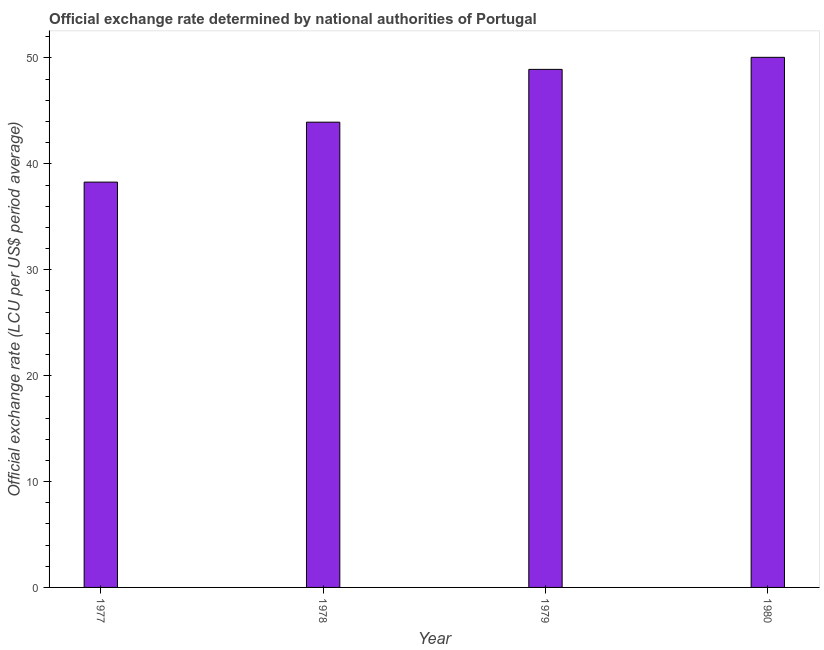Does the graph contain grids?
Provide a succinct answer. No. What is the title of the graph?
Keep it short and to the point. Official exchange rate determined by national authorities of Portugal. What is the label or title of the X-axis?
Offer a very short reply. Year. What is the label or title of the Y-axis?
Offer a terse response. Official exchange rate (LCU per US$ period average). What is the official exchange rate in 1978?
Your answer should be very brief. 43.94. Across all years, what is the maximum official exchange rate?
Make the answer very short. 50.06. Across all years, what is the minimum official exchange rate?
Your answer should be compact. 38.28. In which year was the official exchange rate maximum?
Your answer should be compact. 1980. What is the sum of the official exchange rate?
Provide a short and direct response. 181.2. What is the difference between the official exchange rate in 1978 and 1979?
Offer a very short reply. -4.99. What is the average official exchange rate per year?
Provide a short and direct response. 45.3. What is the median official exchange rate?
Offer a terse response. 46.43. In how many years, is the official exchange rate greater than 36 ?
Ensure brevity in your answer.  4. What is the ratio of the official exchange rate in 1977 to that in 1978?
Make the answer very short. 0.87. Is the official exchange rate in 1977 less than that in 1980?
Give a very brief answer. Yes. What is the difference between the highest and the second highest official exchange rate?
Keep it short and to the point. 1.14. What is the difference between the highest and the lowest official exchange rate?
Offer a very short reply. 11.79. In how many years, is the official exchange rate greater than the average official exchange rate taken over all years?
Provide a succinct answer. 2. How many years are there in the graph?
Give a very brief answer. 4. What is the Official exchange rate (LCU per US$ period average) in 1977?
Offer a very short reply. 38.28. What is the Official exchange rate (LCU per US$ period average) of 1978?
Your answer should be very brief. 43.94. What is the Official exchange rate (LCU per US$ period average) in 1979?
Ensure brevity in your answer.  48.92. What is the Official exchange rate (LCU per US$ period average) of 1980?
Your answer should be very brief. 50.06. What is the difference between the Official exchange rate (LCU per US$ period average) in 1977 and 1978?
Your response must be concise. -5.66. What is the difference between the Official exchange rate (LCU per US$ period average) in 1977 and 1979?
Give a very brief answer. -10.65. What is the difference between the Official exchange rate (LCU per US$ period average) in 1977 and 1980?
Make the answer very short. -11.79. What is the difference between the Official exchange rate (LCU per US$ period average) in 1978 and 1979?
Keep it short and to the point. -4.99. What is the difference between the Official exchange rate (LCU per US$ period average) in 1978 and 1980?
Your response must be concise. -6.12. What is the difference between the Official exchange rate (LCU per US$ period average) in 1979 and 1980?
Your answer should be very brief. -1.14. What is the ratio of the Official exchange rate (LCU per US$ period average) in 1977 to that in 1978?
Your answer should be compact. 0.87. What is the ratio of the Official exchange rate (LCU per US$ period average) in 1977 to that in 1979?
Provide a short and direct response. 0.78. What is the ratio of the Official exchange rate (LCU per US$ period average) in 1977 to that in 1980?
Provide a succinct answer. 0.77. What is the ratio of the Official exchange rate (LCU per US$ period average) in 1978 to that in 1979?
Your answer should be compact. 0.9. What is the ratio of the Official exchange rate (LCU per US$ period average) in 1978 to that in 1980?
Offer a terse response. 0.88. What is the ratio of the Official exchange rate (LCU per US$ period average) in 1979 to that in 1980?
Ensure brevity in your answer.  0.98. 